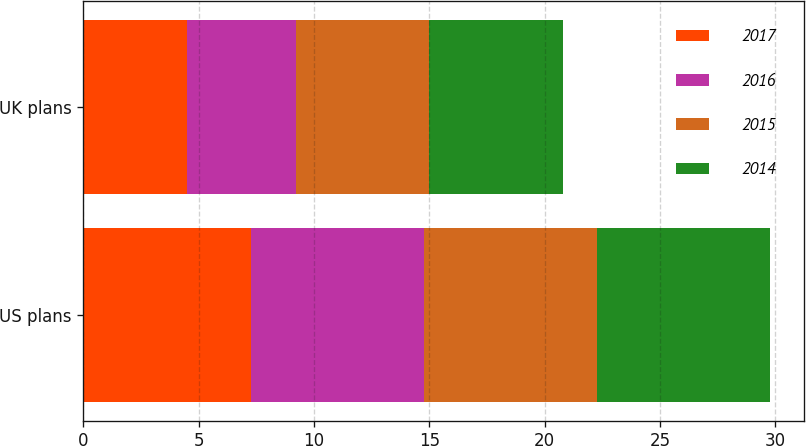<chart> <loc_0><loc_0><loc_500><loc_500><stacked_bar_chart><ecel><fcel>US plans<fcel>UK plans<nl><fcel>2017<fcel>7.25<fcel>4.5<nl><fcel>2016<fcel>7.5<fcel>4.7<nl><fcel>2015<fcel>7.5<fcel>5.8<nl><fcel>2014<fcel>7.5<fcel>5.8<nl></chart> 